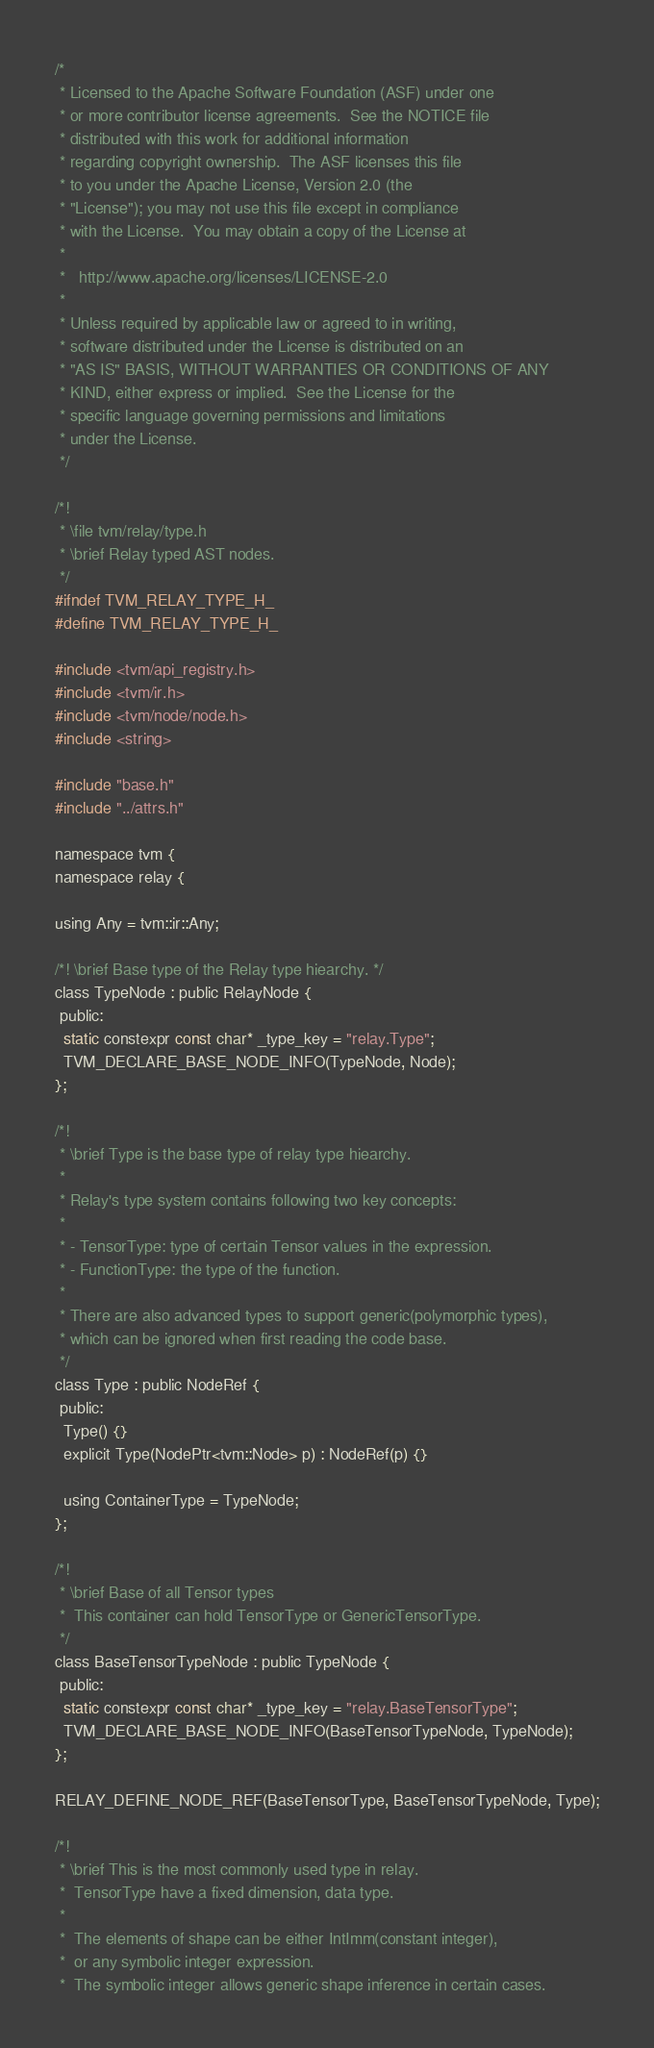<code> <loc_0><loc_0><loc_500><loc_500><_C_>/*
 * Licensed to the Apache Software Foundation (ASF) under one
 * or more contributor license agreements.  See the NOTICE file
 * distributed with this work for additional information
 * regarding copyright ownership.  The ASF licenses this file
 * to you under the Apache License, Version 2.0 (the
 * "License"); you may not use this file except in compliance
 * with the License.  You may obtain a copy of the License at
 *
 *   http://www.apache.org/licenses/LICENSE-2.0
 *
 * Unless required by applicable law or agreed to in writing,
 * software distributed under the License is distributed on an
 * "AS IS" BASIS, WITHOUT WARRANTIES OR CONDITIONS OF ANY
 * KIND, either express or implied.  See the License for the
 * specific language governing permissions and limitations
 * under the License.
 */

/*!
 * \file tvm/relay/type.h
 * \brief Relay typed AST nodes.
 */
#ifndef TVM_RELAY_TYPE_H_
#define TVM_RELAY_TYPE_H_

#include <tvm/api_registry.h>
#include <tvm/ir.h>
#include <tvm/node/node.h>
#include <string>

#include "base.h"
#include "../attrs.h"

namespace tvm {
namespace relay {

using Any = tvm::ir::Any;

/*! \brief Base type of the Relay type hiearchy. */
class TypeNode : public RelayNode {
 public:
  static constexpr const char* _type_key = "relay.Type";
  TVM_DECLARE_BASE_NODE_INFO(TypeNode, Node);
};

/*!
 * \brief Type is the base type of relay type hiearchy.
 *
 * Relay's type system contains following two key concepts:
 *
 * - TensorType: type of certain Tensor values in the expression.
 * - FunctionType: the type of the function.
 *
 * There are also advanced types to support generic(polymorphic types),
 * which can be ignored when first reading the code base.
 */
class Type : public NodeRef {
 public:
  Type() {}
  explicit Type(NodePtr<tvm::Node> p) : NodeRef(p) {}

  using ContainerType = TypeNode;
};

/*!
 * \brief Base of all Tensor types
 *  This container can hold TensorType or GenericTensorType.
 */
class BaseTensorTypeNode : public TypeNode {
 public:
  static constexpr const char* _type_key = "relay.BaseTensorType";
  TVM_DECLARE_BASE_NODE_INFO(BaseTensorTypeNode, TypeNode);
};

RELAY_DEFINE_NODE_REF(BaseTensorType, BaseTensorTypeNode, Type);

/*!
 * \brief This is the most commonly used type in relay.
 *  TensorType have a fixed dimension, data type.
 *
 *  The elements of shape can be either IntImm(constant integer),
 *  or any symbolic integer expression.
 *  The symbolic integer allows generic shape inference in certain cases.</code> 